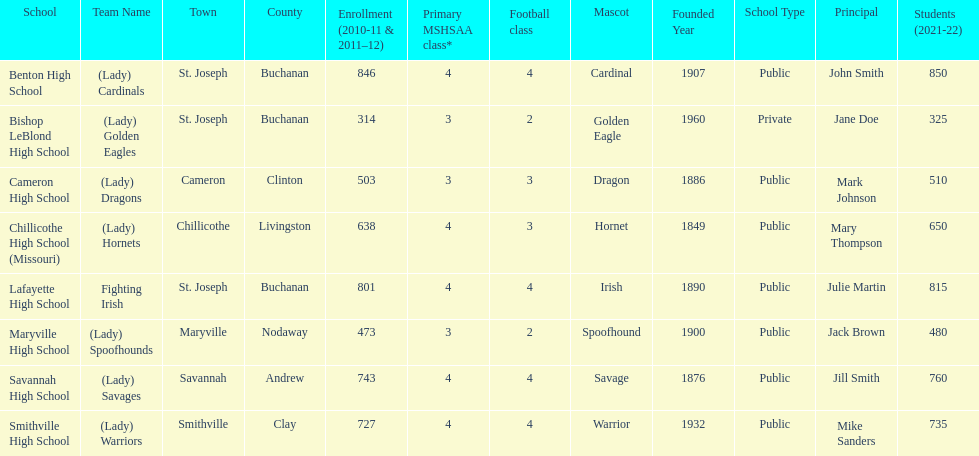What's the count of schools participating in this conference? 8. 